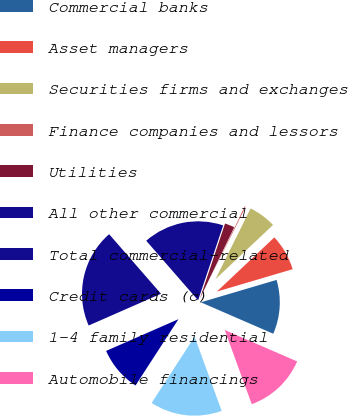Convert chart to OTSL. <chart><loc_0><loc_0><loc_500><loc_500><pie_chart><fcel>Commercial banks<fcel>Asset managers<fcel>Securities firms and exchanges<fcel>Finance companies and lessors<fcel>Utilities<fcel>All other commercial<fcel>Total commercial-related<fcel>Credit cards (c)<fcel>1-4 family residential<fcel>Automobile financings<nl><fcel>11.09%<fcel>7.46%<fcel>5.64%<fcel>0.19%<fcel>2.0%<fcel>16.54%<fcel>20.18%<fcel>9.27%<fcel>14.72%<fcel>12.91%<nl></chart> 